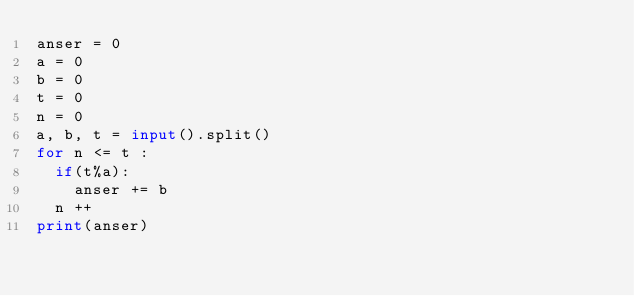<code> <loc_0><loc_0><loc_500><loc_500><_Python_>anser = 0
a = 0
b = 0
t = 0
n = 0
a, b, t = input().split()
for n <= t :
  if(t%a):
    anser += b
  n ++
print(anser)</code> 